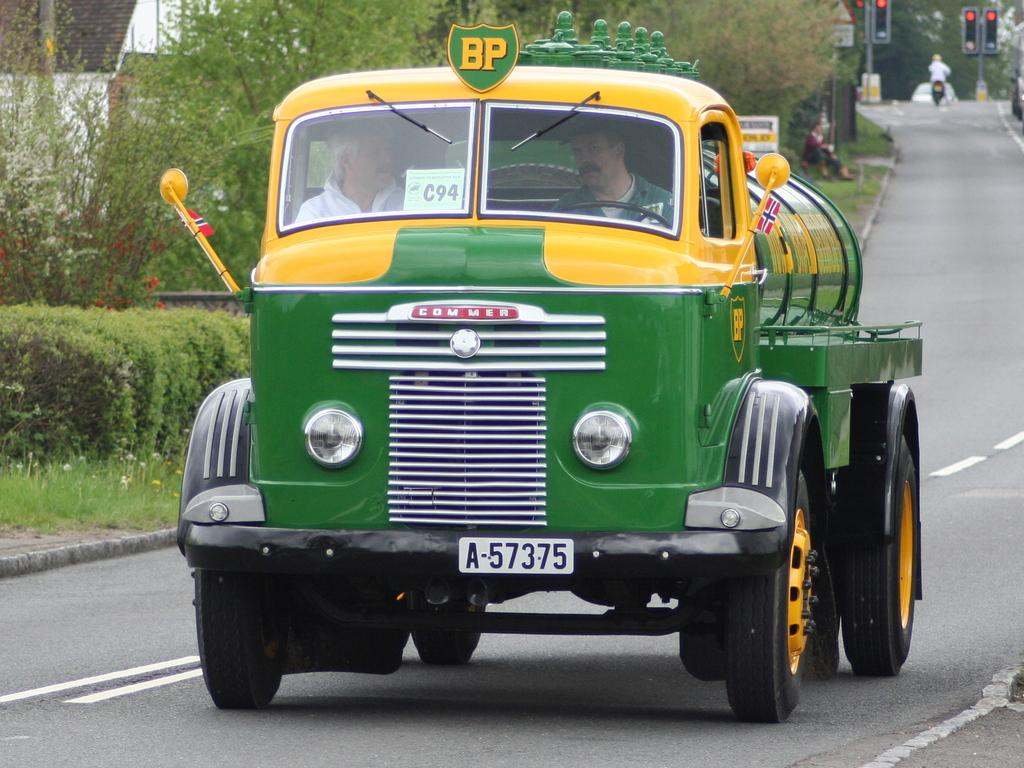<image>
Present a compact description of the photo's key features. An old yellow and green Commer truck with the license plate A-57375 drives down a road. 